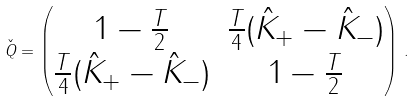<formula> <loc_0><loc_0><loc_500><loc_500>\check { Q } = \begin{pmatrix} 1 - \frac { T } { 2 } & \frac { T } { 4 } ( \hat { K } _ { + } - \hat { K } _ { - } ) \\ \frac { T } { 4 } ( \hat { K } _ { + } - \hat { K } _ { - } ) & 1 - \frac { T } { 2 } \end{pmatrix} \, .</formula> 